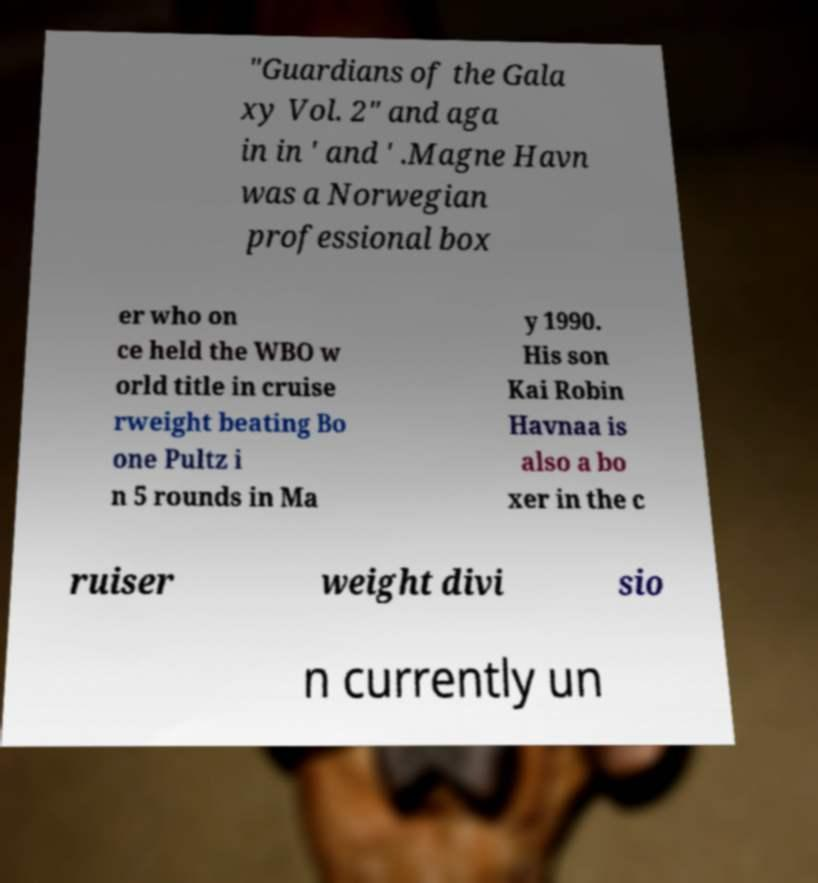There's text embedded in this image that I need extracted. Can you transcribe it verbatim? "Guardians of the Gala xy Vol. 2" and aga in in ' and ' .Magne Havn was a Norwegian professional box er who on ce held the WBO w orld title in cruise rweight beating Bo one Pultz i n 5 rounds in Ma y 1990. His son Kai Robin Havnaa is also a bo xer in the c ruiser weight divi sio n currently un 